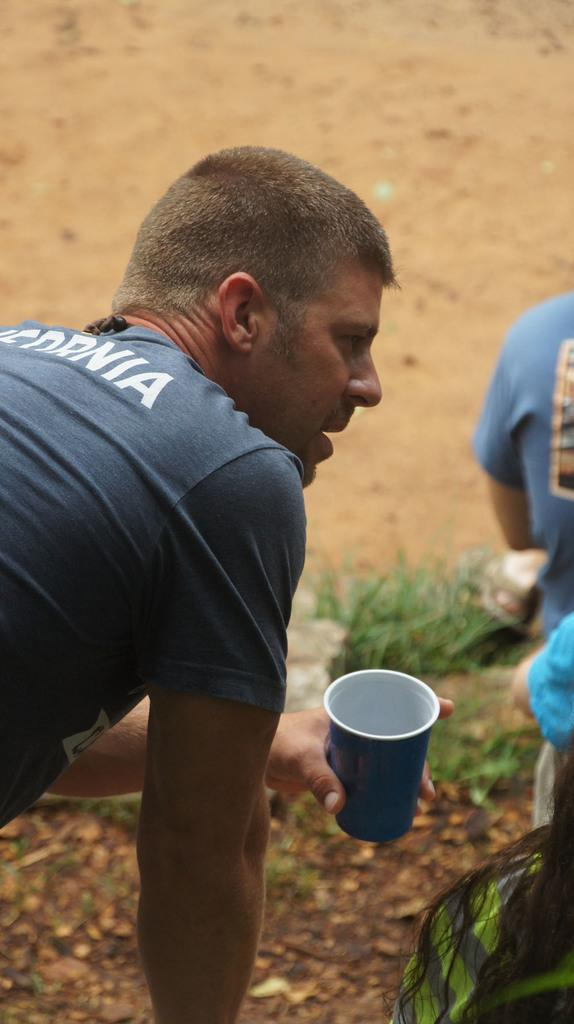What type of vegetation can be seen in the image? There is grass in the image. How many people are present in the image? There are three people in the image. What material is present in the image that is typically transparent? There is glass in the image. What type of approval is being given by the people in the image? There is no indication of approval or any related action in the image; it only shows three people and grass. Can you tell me what color the balloon is in the image? There is no balloon present in the image. 